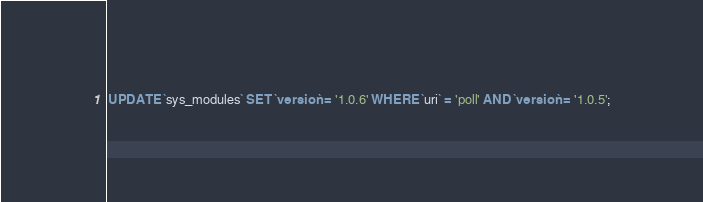Convert code to text. <code><loc_0><loc_0><loc_500><loc_500><_SQL_>

UPDATE `sys_modules` SET `version` = '1.0.6' WHERE `uri` = 'poll' AND `version` = '1.0.5';

</code> 